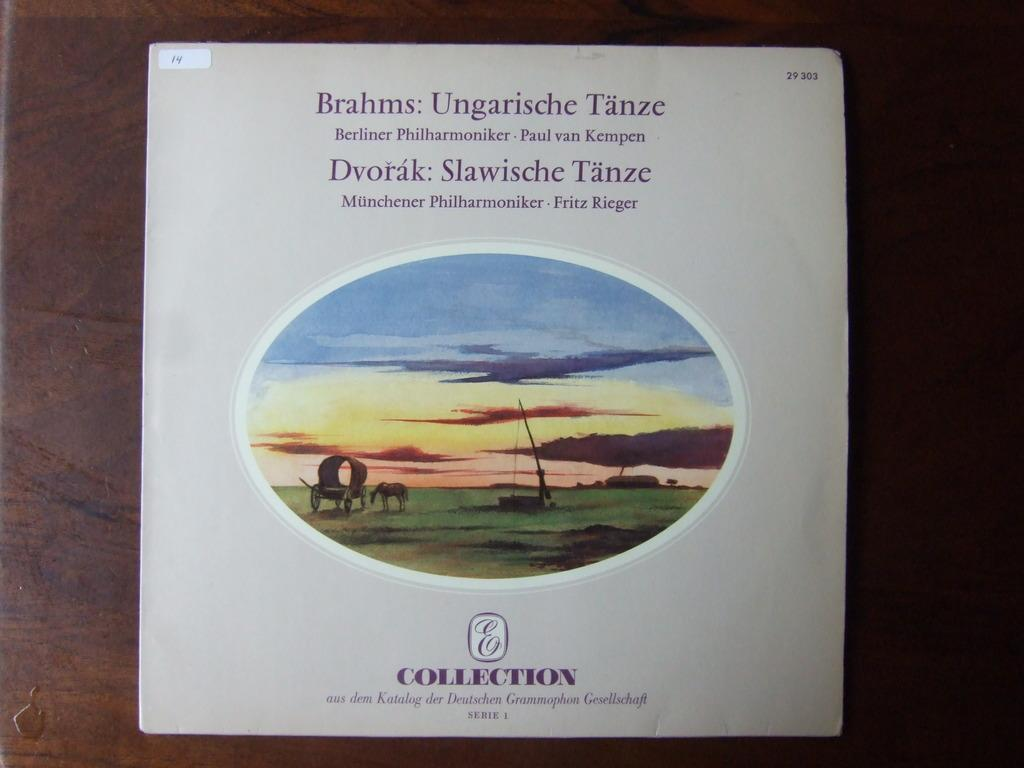<image>
Offer a succinct explanation of the picture presented. A CD cover for Brahms: Ungarische Tanze serie i. 